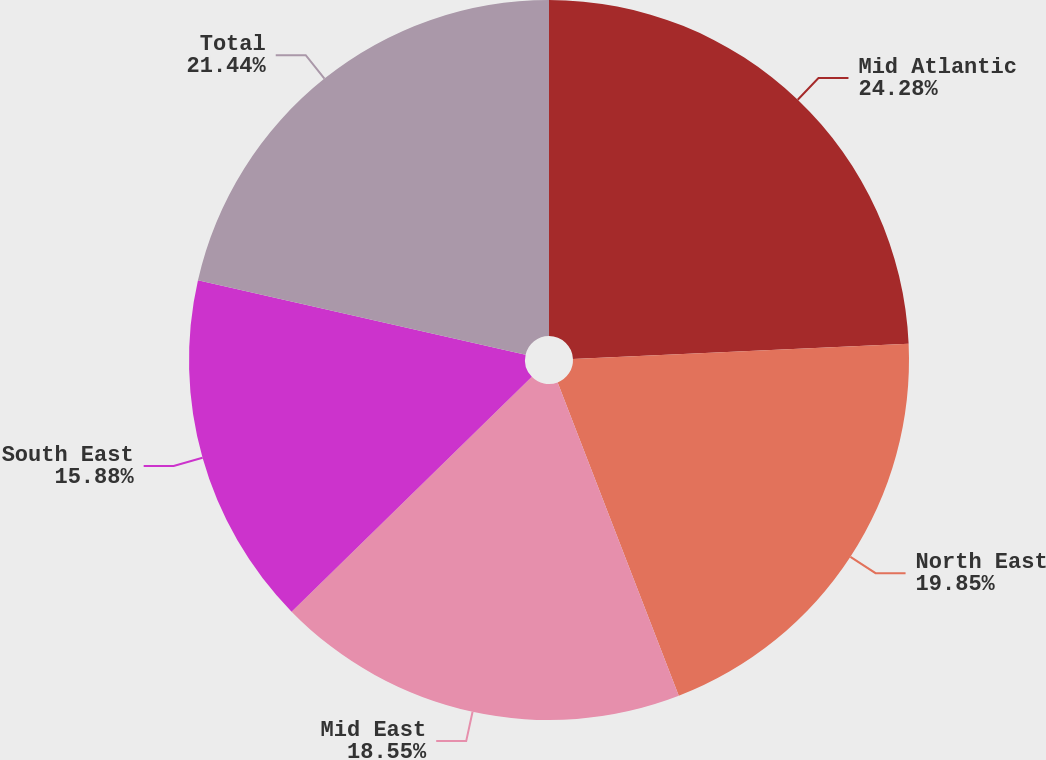<chart> <loc_0><loc_0><loc_500><loc_500><pie_chart><fcel>Mid Atlantic<fcel>North East<fcel>Mid East<fcel>South East<fcel>Total<nl><fcel>24.28%<fcel>19.85%<fcel>18.55%<fcel>15.88%<fcel>21.44%<nl></chart> 